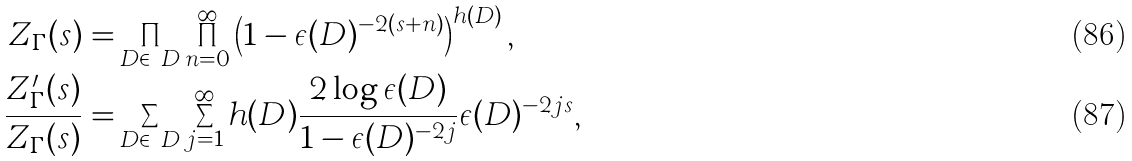Convert formula to latex. <formula><loc_0><loc_0><loc_500><loc_500>Z _ { \Gamma } ( s ) = & \prod _ { D \in \ D } \prod _ { n = 0 } ^ { \infty } \left ( 1 - \epsilon ( D ) ^ { - 2 ( s + n ) } \right ) ^ { h ( D ) } , \\ \frac { Z ^ { \prime } _ { \Gamma } ( s ) } { Z _ { \Gamma } ( s ) } = & \sum _ { D \in \ D } \sum _ { j = 1 } ^ { \infty } h ( D ) \frac { 2 \log { \epsilon ( D ) } } { 1 - \epsilon ( D ) ^ { - 2 j } } \epsilon ( D ) ^ { - 2 j s } ,</formula> 